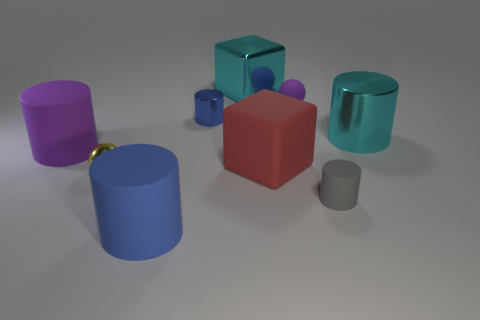What is the size of the metallic object that is the same color as the big shiny cylinder?
Ensure brevity in your answer.  Large. Does the blue cylinder behind the matte cube have the same size as the cyan cylinder behind the shiny sphere?
Provide a short and direct response. No. What is the size of the cylinder that is to the left of the gray object and in front of the purple cylinder?
Provide a succinct answer. Large. What color is the tiny rubber object that is the same shape as the big blue rubber thing?
Provide a short and direct response. Gray. Are there more big matte cylinders behind the large cyan block than cylinders that are in front of the large blue object?
Keep it short and to the point. No. What number of other objects are there of the same shape as the tiny blue metallic object?
Offer a terse response. 4. Is there a yellow object behind the ball right of the big shiny block?
Give a very brief answer. No. How many yellow objects are there?
Provide a succinct answer. 1. Does the tiny rubber ball have the same color as the large object that is behind the large cyan metal cylinder?
Ensure brevity in your answer.  No. Are there more tiny red rubber balls than big cyan shiny things?
Make the answer very short. No. 